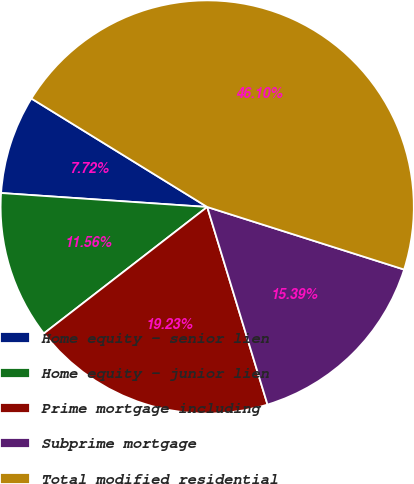Convert chart to OTSL. <chart><loc_0><loc_0><loc_500><loc_500><pie_chart><fcel>Home equity - senior lien<fcel>Home equity - junior lien<fcel>Prime mortgage including<fcel>Subprime mortgage<fcel>Total modified residential<nl><fcel>7.72%<fcel>11.56%<fcel>19.23%<fcel>15.39%<fcel>46.1%<nl></chart> 